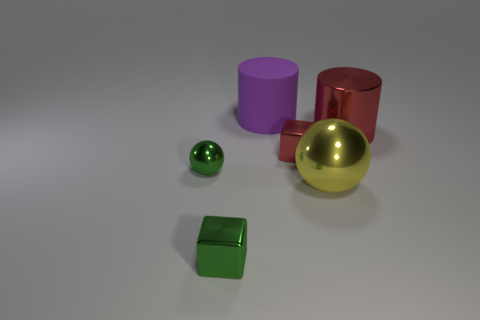Is the large yellow sphere made of the same material as the small ball?
Keep it short and to the point. Yes. What material is the small object that is the same color as the shiny cylinder?
Your answer should be compact. Metal. What is the color of the small metal sphere?
Keep it short and to the point. Green. Is there any other thing of the same color as the large metal sphere?
Your response must be concise. No. There is another big thing that is the same shape as the rubber thing; what is its color?
Offer a very short reply. Red. What is the size of the object that is behind the tiny red block and on the left side of the yellow metallic ball?
Your response must be concise. Large. There is a tiny metal object that is left of the green block; does it have the same shape as the red shiny object that is to the left of the red cylinder?
Your answer should be very brief. No. There is a object that is the same color as the metallic cylinder; what is its shape?
Ensure brevity in your answer.  Cube. How many small green things have the same material as the yellow thing?
Provide a short and direct response. 2. What is the shape of the metallic object that is both behind the green metallic sphere and in front of the red cylinder?
Your answer should be compact. Cube. 